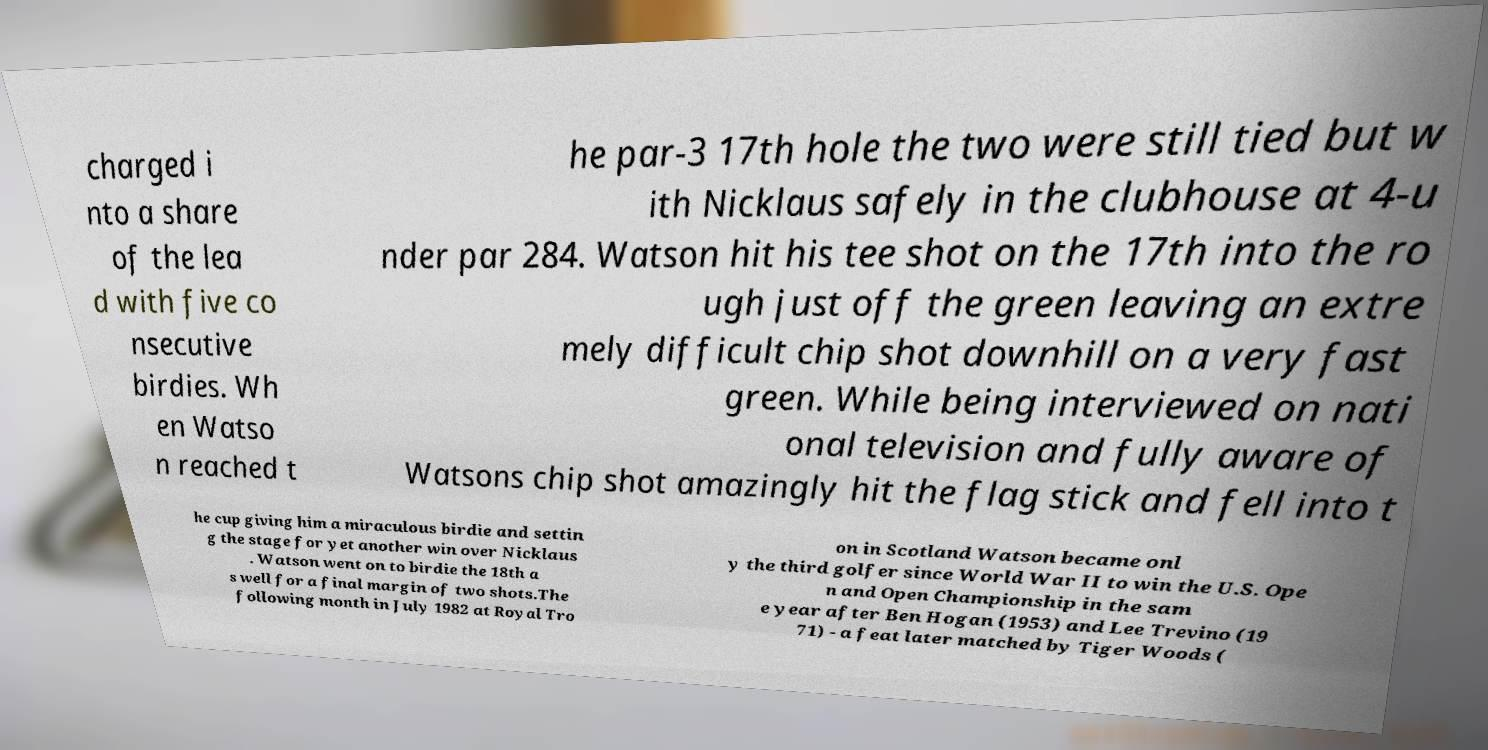Please read and relay the text visible in this image. What does it say? charged i nto a share of the lea d with five co nsecutive birdies. Wh en Watso n reached t he par-3 17th hole the two were still tied but w ith Nicklaus safely in the clubhouse at 4-u nder par 284. Watson hit his tee shot on the 17th into the ro ugh just off the green leaving an extre mely difficult chip shot downhill on a very fast green. While being interviewed on nati onal television and fully aware of Watsons chip shot amazingly hit the flag stick and fell into t he cup giving him a miraculous birdie and settin g the stage for yet another win over Nicklaus . Watson went on to birdie the 18th a s well for a final margin of two shots.The following month in July 1982 at Royal Tro on in Scotland Watson became onl y the third golfer since World War II to win the U.S. Ope n and Open Championship in the sam e year after Ben Hogan (1953) and Lee Trevino (19 71) - a feat later matched by Tiger Woods ( 